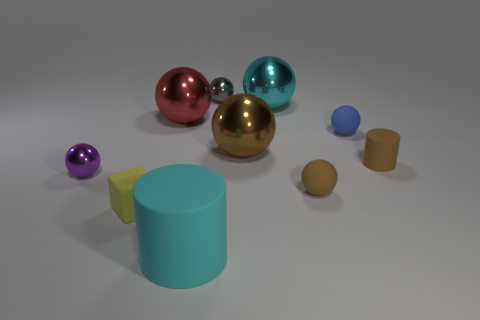Subtract all brown spheres. How many spheres are left? 5 Subtract all brown cylinders. How many cylinders are left? 1 Subtract all cylinders. How many objects are left? 8 Subtract all yellow cubes. How many brown balls are left? 2 Add 2 tiny matte cylinders. How many tiny matte cylinders exist? 3 Subtract 1 brown cylinders. How many objects are left? 9 Subtract all blue blocks. Subtract all cyan balls. How many blocks are left? 1 Subtract all tiny purple cylinders. Subtract all red spheres. How many objects are left? 9 Add 5 tiny yellow matte objects. How many tiny yellow matte objects are left? 6 